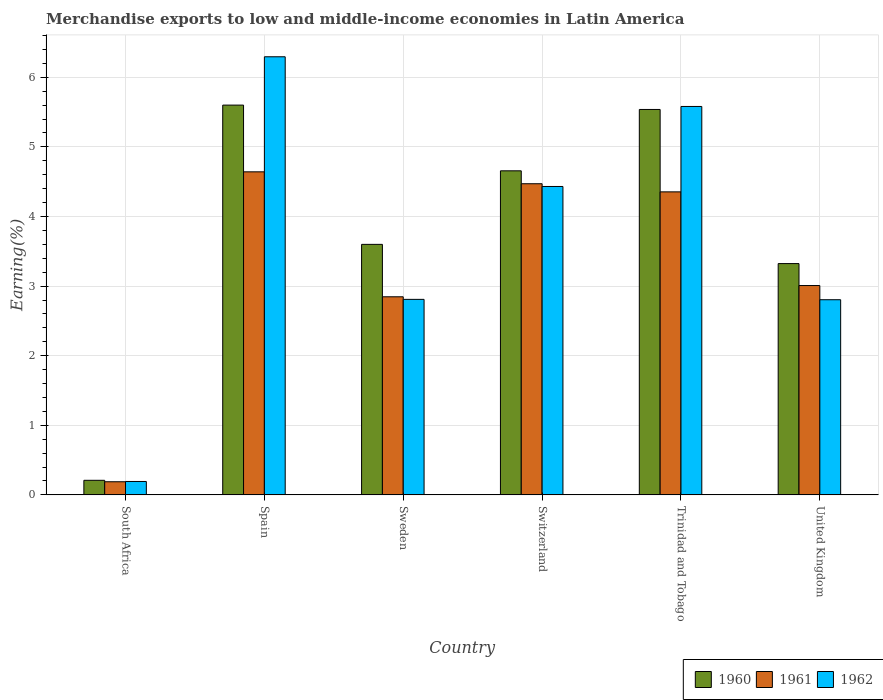How many different coloured bars are there?
Your answer should be compact. 3. How many bars are there on the 2nd tick from the right?
Provide a succinct answer. 3. In how many cases, is the number of bars for a given country not equal to the number of legend labels?
Ensure brevity in your answer.  0. What is the percentage of amount earned from merchandise exports in 1960 in Sweden?
Make the answer very short. 3.6. Across all countries, what is the maximum percentage of amount earned from merchandise exports in 1962?
Your answer should be compact. 6.3. Across all countries, what is the minimum percentage of amount earned from merchandise exports in 1960?
Your response must be concise. 0.21. In which country was the percentage of amount earned from merchandise exports in 1962 maximum?
Offer a terse response. Spain. In which country was the percentage of amount earned from merchandise exports in 1960 minimum?
Make the answer very short. South Africa. What is the total percentage of amount earned from merchandise exports in 1961 in the graph?
Ensure brevity in your answer.  19.51. What is the difference between the percentage of amount earned from merchandise exports in 1960 in South Africa and that in Spain?
Keep it short and to the point. -5.39. What is the difference between the percentage of amount earned from merchandise exports in 1960 in Spain and the percentage of amount earned from merchandise exports in 1961 in South Africa?
Offer a terse response. 5.41. What is the average percentage of amount earned from merchandise exports in 1962 per country?
Ensure brevity in your answer.  3.69. What is the difference between the percentage of amount earned from merchandise exports of/in 1961 and percentage of amount earned from merchandise exports of/in 1962 in Sweden?
Offer a terse response. 0.04. In how many countries, is the percentage of amount earned from merchandise exports in 1962 greater than 2.8 %?
Provide a succinct answer. 5. What is the ratio of the percentage of amount earned from merchandise exports in 1962 in South Africa to that in Switzerland?
Provide a short and direct response. 0.04. What is the difference between the highest and the second highest percentage of amount earned from merchandise exports in 1962?
Provide a succinct answer. -1.15. What is the difference between the highest and the lowest percentage of amount earned from merchandise exports in 1961?
Make the answer very short. 4.45. What does the 1st bar from the left in South Africa represents?
Keep it short and to the point. 1960. What does the 1st bar from the right in Spain represents?
Keep it short and to the point. 1962. How many bars are there?
Keep it short and to the point. 18. Are all the bars in the graph horizontal?
Ensure brevity in your answer.  No. How many countries are there in the graph?
Offer a very short reply. 6. Are the values on the major ticks of Y-axis written in scientific E-notation?
Your answer should be very brief. No. Does the graph contain grids?
Offer a very short reply. Yes. Where does the legend appear in the graph?
Ensure brevity in your answer.  Bottom right. How are the legend labels stacked?
Offer a very short reply. Horizontal. What is the title of the graph?
Make the answer very short. Merchandise exports to low and middle-income economies in Latin America. What is the label or title of the X-axis?
Your answer should be very brief. Country. What is the label or title of the Y-axis?
Provide a succinct answer. Earning(%). What is the Earning(%) in 1960 in South Africa?
Offer a terse response. 0.21. What is the Earning(%) of 1961 in South Africa?
Provide a short and direct response. 0.19. What is the Earning(%) of 1962 in South Africa?
Your answer should be very brief. 0.19. What is the Earning(%) in 1960 in Spain?
Your answer should be compact. 5.6. What is the Earning(%) of 1961 in Spain?
Provide a short and direct response. 4.64. What is the Earning(%) in 1962 in Spain?
Offer a terse response. 6.3. What is the Earning(%) of 1960 in Sweden?
Provide a short and direct response. 3.6. What is the Earning(%) in 1961 in Sweden?
Offer a very short reply. 2.85. What is the Earning(%) of 1962 in Sweden?
Make the answer very short. 2.81. What is the Earning(%) of 1960 in Switzerland?
Give a very brief answer. 4.66. What is the Earning(%) of 1961 in Switzerland?
Keep it short and to the point. 4.47. What is the Earning(%) of 1962 in Switzerland?
Make the answer very short. 4.43. What is the Earning(%) of 1960 in Trinidad and Tobago?
Keep it short and to the point. 5.54. What is the Earning(%) of 1961 in Trinidad and Tobago?
Provide a short and direct response. 4.35. What is the Earning(%) of 1962 in Trinidad and Tobago?
Give a very brief answer. 5.58. What is the Earning(%) in 1960 in United Kingdom?
Ensure brevity in your answer.  3.32. What is the Earning(%) in 1961 in United Kingdom?
Your response must be concise. 3.01. What is the Earning(%) of 1962 in United Kingdom?
Offer a very short reply. 2.8. Across all countries, what is the maximum Earning(%) in 1960?
Offer a terse response. 5.6. Across all countries, what is the maximum Earning(%) of 1961?
Your answer should be compact. 4.64. Across all countries, what is the maximum Earning(%) in 1962?
Provide a succinct answer. 6.3. Across all countries, what is the minimum Earning(%) in 1960?
Give a very brief answer. 0.21. Across all countries, what is the minimum Earning(%) of 1961?
Your response must be concise. 0.19. Across all countries, what is the minimum Earning(%) of 1962?
Your response must be concise. 0.19. What is the total Earning(%) of 1960 in the graph?
Provide a succinct answer. 22.93. What is the total Earning(%) in 1961 in the graph?
Make the answer very short. 19.51. What is the total Earning(%) in 1962 in the graph?
Your answer should be compact. 22.11. What is the difference between the Earning(%) in 1960 in South Africa and that in Spain?
Ensure brevity in your answer.  -5.39. What is the difference between the Earning(%) of 1961 in South Africa and that in Spain?
Ensure brevity in your answer.  -4.45. What is the difference between the Earning(%) of 1962 in South Africa and that in Spain?
Offer a terse response. -6.1. What is the difference between the Earning(%) of 1960 in South Africa and that in Sweden?
Ensure brevity in your answer.  -3.39. What is the difference between the Earning(%) in 1961 in South Africa and that in Sweden?
Offer a very short reply. -2.66. What is the difference between the Earning(%) in 1962 in South Africa and that in Sweden?
Your answer should be very brief. -2.62. What is the difference between the Earning(%) of 1960 in South Africa and that in Switzerland?
Provide a succinct answer. -4.45. What is the difference between the Earning(%) of 1961 in South Africa and that in Switzerland?
Your answer should be very brief. -4.28. What is the difference between the Earning(%) of 1962 in South Africa and that in Switzerland?
Provide a short and direct response. -4.24. What is the difference between the Earning(%) of 1960 in South Africa and that in Trinidad and Tobago?
Offer a terse response. -5.33. What is the difference between the Earning(%) of 1961 in South Africa and that in Trinidad and Tobago?
Provide a succinct answer. -4.17. What is the difference between the Earning(%) in 1962 in South Africa and that in Trinidad and Tobago?
Your response must be concise. -5.39. What is the difference between the Earning(%) of 1960 in South Africa and that in United Kingdom?
Make the answer very short. -3.11. What is the difference between the Earning(%) in 1961 in South Africa and that in United Kingdom?
Make the answer very short. -2.82. What is the difference between the Earning(%) of 1962 in South Africa and that in United Kingdom?
Your answer should be very brief. -2.61. What is the difference between the Earning(%) of 1960 in Spain and that in Sweden?
Offer a very short reply. 2. What is the difference between the Earning(%) of 1961 in Spain and that in Sweden?
Keep it short and to the point. 1.8. What is the difference between the Earning(%) in 1962 in Spain and that in Sweden?
Make the answer very short. 3.49. What is the difference between the Earning(%) in 1960 in Spain and that in Switzerland?
Your answer should be compact. 0.94. What is the difference between the Earning(%) of 1961 in Spain and that in Switzerland?
Give a very brief answer. 0.17. What is the difference between the Earning(%) of 1962 in Spain and that in Switzerland?
Offer a terse response. 1.86. What is the difference between the Earning(%) in 1960 in Spain and that in Trinidad and Tobago?
Make the answer very short. 0.06. What is the difference between the Earning(%) of 1961 in Spain and that in Trinidad and Tobago?
Your response must be concise. 0.29. What is the difference between the Earning(%) in 1962 in Spain and that in Trinidad and Tobago?
Make the answer very short. 0.71. What is the difference between the Earning(%) of 1960 in Spain and that in United Kingdom?
Keep it short and to the point. 2.28. What is the difference between the Earning(%) in 1961 in Spain and that in United Kingdom?
Give a very brief answer. 1.63. What is the difference between the Earning(%) of 1962 in Spain and that in United Kingdom?
Your answer should be compact. 3.49. What is the difference between the Earning(%) of 1960 in Sweden and that in Switzerland?
Ensure brevity in your answer.  -1.06. What is the difference between the Earning(%) of 1961 in Sweden and that in Switzerland?
Offer a very short reply. -1.62. What is the difference between the Earning(%) of 1962 in Sweden and that in Switzerland?
Ensure brevity in your answer.  -1.62. What is the difference between the Earning(%) in 1960 in Sweden and that in Trinidad and Tobago?
Give a very brief answer. -1.94. What is the difference between the Earning(%) of 1961 in Sweden and that in Trinidad and Tobago?
Make the answer very short. -1.51. What is the difference between the Earning(%) of 1962 in Sweden and that in Trinidad and Tobago?
Your response must be concise. -2.77. What is the difference between the Earning(%) in 1960 in Sweden and that in United Kingdom?
Your answer should be compact. 0.28. What is the difference between the Earning(%) in 1961 in Sweden and that in United Kingdom?
Offer a very short reply. -0.16. What is the difference between the Earning(%) in 1962 in Sweden and that in United Kingdom?
Your answer should be compact. 0.01. What is the difference between the Earning(%) of 1960 in Switzerland and that in Trinidad and Tobago?
Make the answer very short. -0.88. What is the difference between the Earning(%) of 1961 in Switzerland and that in Trinidad and Tobago?
Provide a short and direct response. 0.12. What is the difference between the Earning(%) of 1962 in Switzerland and that in Trinidad and Tobago?
Ensure brevity in your answer.  -1.15. What is the difference between the Earning(%) in 1960 in Switzerland and that in United Kingdom?
Your answer should be compact. 1.33. What is the difference between the Earning(%) in 1961 in Switzerland and that in United Kingdom?
Your response must be concise. 1.46. What is the difference between the Earning(%) in 1962 in Switzerland and that in United Kingdom?
Keep it short and to the point. 1.63. What is the difference between the Earning(%) of 1960 in Trinidad and Tobago and that in United Kingdom?
Provide a succinct answer. 2.21. What is the difference between the Earning(%) in 1961 in Trinidad and Tobago and that in United Kingdom?
Ensure brevity in your answer.  1.35. What is the difference between the Earning(%) in 1962 in Trinidad and Tobago and that in United Kingdom?
Ensure brevity in your answer.  2.78. What is the difference between the Earning(%) of 1960 in South Africa and the Earning(%) of 1961 in Spain?
Offer a very short reply. -4.43. What is the difference between the Earning(%) in 1960 in South Africa and the Earning(%) in 1962 in Spain?
Provide a short and direct response. -6.09. What is the difference between the Earning(%) in 1961 in South Africa and the Earning(%) in 1962 in Spain?
Ensure brevity in your answer.  -6.11. What is the difference between the Earning(%) of 1960 in South Africa and the Earning(%) of 1961 in Sweden?
Keep it short and to the point. -2.64. What is the difference between the Earning(%) of 1960 in South Africa and the Earning(%) of 1962 in Sweden?
Provide a short and direct response. -2.6. What is the difference between the Earning(%) in 1961 in South Africa and the Earning(%) in 1962 in Sweden?
Keep it short and to the point. -2.62. What is the difference between the Earning(%) of 1960 in South Africa and the Earning(%) of 1961 in Switzerland?
Provide a short and direct response. -4.26. What is the difference between the Earning(%) of 1960 in South Africa and the Earning(%) of 1962 in Switzerland?
Your answer should be very brief. -4.22. What is the difference between the Earning(%) in 1961 in South Africa and the Earning(%) in 1962 in Switzerland?
Your answer should be very brief. -4.24. What is the difference between the Earning(%) of 1960 in South Africa and the Earning(%) of 1961 in Trinidad and Tobago?
Your answer should be very brief. -4.14. What is the difference between the Earning(%) in 1960 in South Africa and the Earning(%) in 1962 in Trinidad and Tobago?
Give a very brief answer. -5.37. What is the difference between the Earning(%) of 1961 in South Africa and the Earning(%) of 1962 in Trinidad and Tobago?
Offer a very short reply. -5.39. What is the difference between the Earning(%) in 1960 in South Africa and the Earning(%) in 1961 in United Kingdom?
Make the answer very short. -2.8. What is the difference between the Earning(%) in 1960 in South Africa and the Earning(%) in 1962 in United Kingdom?
Your answer should be very brief. -2.59. What is the difference between the Earning(%) in 1961 in South Africa and the Earning(%) in 1962 in United Kingdom?
Your answer should be compact. -2.62. What is the difference between the Earning(%) in 1960 in Spain and the Earning(%) in 1961 in Sweden?
Provide a succinct answer. 2.75. What is the difference between the Earning(%) of 1960 in Spain and the Earning(%) of 1962 in Sweden?
Ensure brevity in your answer.  2.79. What is the difference between the Earning(%) of 1961 in Spain and the Earning(%) of 1962 in Sweden?
Make the answer very short. 1.83. What is the difference between the Earning(%) in 1960 in Spain and the Earning(%) in 1961 in Switzerland?
Your response must be concise. 1.13. What is the difference between the Earning(%) in 1960 in Spain and the Earning(%) in 1962 in Switzerland?
Offer a very short reply. 1.17. What is the difference between the Earning(%) in 1961 in Spain and the Earning(%) in 1962 in Switzerland?
Your answer should be compact. 0.21. What is the difference between the Earning(%) of 1960 in Spain and the Earning(%) of 1961 in Trinidad and Tobago?
Offer a terse response. 1.25. What is the difference between the Earning(%) of 1960 in Spain and the Earning(%) of 1962 in Trinidad and Tobago?
Your response must be concise. 0.02. What is the difference between the Earning(%) in 1961 in Spain and the Earning(%) in 1962 in Trinidad and Tobago?
Offer a very short reply. -0.94. What is the difference between the Earning(%) in 1960 in Spain and the Earning(%) in 1961 in United Kingdom?
Keep it short and to the point. 2.59. What is the difference between the Earning(%) in 1960 in Spain and the Earning(%) in 1962 in United Kingdom?
Your answer should be compact. 2.8. What is the difference between the Earning(%) in 1961 in Spain and the Earning(%) in 1962 in United Kingdom?
Your answer should be very brief. 1.84. What is the difference between the Earning(%) of 1960 in Sweden and the Earning(%) of 1961 in Switzerland?
Provide a short and direct response. -0.87. What is the difference between the Earning(%) in 1960 in Sweden and the Earning(%) in 1962 in Switzerland?
Keep it short and to the point. -0.83. What is the difference between the Earning(%) in 1961 in Sweden and the Earning(%) in 1962 in Switzerland?
Ensure brevity in your answer.  -1.58. What is the difference between the Earning(%) of 1960 in Sweden and the Earning(%) of 1961 in Trinidad and Tobago?
Provide a short and direct response. -0.75. What is the difference between the Earning(%) in 1960 in Sweden and the Earning(%) in 1962 in Trinidad and Tobago?
Offer a terse response. -1.98. What is the difference between the Earning(%) of 1961 in Sweden and the Earning(%) of 1962 in Trinidad and Tobago?
Make the answer very short. -2.73. What is the difference between the Earning(%) of 1960 in Sweden and the Earning(%) of 1961 in United Kingdom?
Your answer should be compact. 0.59. What is the difference between the Earning(%) in 1960 in Sweden and the Earning(%) in 1962 in United Kingdom?
Provide a succinct answer. 0.8. What is the difference between the Earning(%) of 1961 in Sweden and the Earning(%) of 1962 in United Kingdom?
Offer a terse response. 0.04. What is the difference between the Earning(%) of 1960 in Switzerland and the Earning(%) of 1961 in Trinidad and Tobago?
Provide a short and direct response. 0.3. What is the difference between the Earning(%) of 1960 in Switzerland and the Earning(%) of 1962 in Trinidad and Tobago?
Provide a succinct answer. -0.92. What is the difference between the Earning(%) in 1961 in Switzerland and the Earning(%) in 1962 in Trinidad and Tobago?
Your response must be concise. -1.11. What is the difference between the Earning(%) in 1960 in Switzerland and the Earning(%) in 1961 in United Kingdom?
Make the answer very short. 1.65. What is the difference between the Earning(%) of 1960 in Switzerland and the Earning(%) of 1962 in United Kingdom?
Give a very brief answer. 1.85. What is the difference between the Earning(%) of 1961 in Switzerland and the Earning(%) of 1962 in United Kingdom?
Provide a succinct answer. 1.67. What is the difference between the Earning(%) of 1960 in Trinidad and Tobago and the Earning(%) of 1961 in United Kingdom?
Your response must be concise. 2.53. What is the difference between the Earning(%) in 1960 in Trinidad and Tobago and the Earning(%) in 1962 in United Kingdom?
Offer a very short reply. 2.73. What is the difference between the Earning(%) in 1961 in Trinidad and Tobago and the Earning(%) in 1962 in United Kingdom?
Make the answer very short. 1.55. What is the average Earning(%) of 1960 per country?
Offer a very short reply. 3.82. What is the average Earning(%) in 1961 per country?
Offer a terse response. 3.25. What is the average Earning(%) in 1962 per country?
Make the answer very short. 3.69. What is the difference between the Earning(%) of 1960 and Earning(%) of 1961 in South Africa?
Provide a succinct answer. 0.02. What is the difference between the Earning(%) of 1960 and Earning(%) of 1962 in South Africa?
Your answer should be compact. 0.02. What is the difference between the Earning(%) in 1961 and Earning(%) in 1962 in South Africa?
Offer a very short reply. -0. What is the difference between the Earning(%) of 1960 and Earning(%) of 1961 in Spain?
Give a very brief answer. 0.96. What is the difference between the Earning(%) in 1960 and Earning(%) in 1962 in Spain?
Your response must be concise. -0.69. What is the difference between the Earning(%) of 1961 and Earning(%) of 1962 in Spain?
Your answer should be very brief. -1.65. What is the difference between the Earning(%) in 1960 and Earning(%) in 1961 in Sweden?
Give a very brief answer. 0.75. What is the difference between the Earning(%) of 1960 and Earning(%) of 1962 in Sweden?
Offer a very short reply. 0.79. What is the difference between the Earning(%) in 1961 and Earning(%) in 1962 in Sweden?
Offer a very short reply. 0.04. What is the difference between the Earning(%) in 1960 and Earning(%) in 1961 in Switzerland?
Provide a succinct answer. 0.19. What is the difference between the Earning(%) of 1960 and Earning(%) of 1962 in Switzerland?
Your response must be concise. 0.23. What is the difference between the Earning(%) in 1961 and Earning(%) in 1962 in Switzerland?
Provide a succinct answer. 0.04. What is the difference between the Earning(%) of 1960 and Earning(%) of 1961 in Trinidad and Tobago?
Ensure brevity in your answer.  1.18. What is the difference between the Earning(%) in 1960 and Earning(%) in 1962 in Trinidad and Tobago?
Make the answer very short. -0.04. What is the difference between the Earning(%) in 1961 and Earning(%) in 1962 in Trinidad and Tobago?
Keep it short and to the point. -1.23. What is the difference between the Earning(%) of 1960 and Earning(%) of 1961 in United Kingdom?
Make the answer very short. 0.32. What is the difference between the Earning(%) in 1960 and Earning(%) in 1962 in United Kingdom?
Provide a short and direct response. 0.52. What is the difference between the Earning(%) of 1961 and Earning(%) of 1962 in United Kingdom?
Keep it short and to the point. 0.2. What is the ratio of the Earning(%) of 1960 in South Africa to that in Spain?
Provide a short and direct response. 0.04. What is the ratio of the Earning(%) in 1961 in South Africa to that in Spain?
Keep it short and to the point. 0.04. What is the ratio of the Earning(%) of 1962 in South Africa to that in Spain?
Your response must be concise. 0.03. What is the ratio of the Earning(%) of 1960 in South Africa to that in Sweden?
Your answer should be very brief. 0.06. What is the ratio of the Earning(%) of 1961 in South Africa to that in Sweden?
Your answer should be compact. 0.07. What is the ratio of the Earning(%) of 1962 in South Africa to that in Sweden?
Your answer should be very brief. 0.07. What is the ratio of the Earning(%) of 1960 in South Africa to that in Switzerland?
Ensure brevity in your answer.  0.04. What is the ratio of the Earning(%) of 1961 in South Africa to that in Switzerland?
Keep it short and to the point. 0.04. What is the ratio of the Earning(%) in 1962 in South Africa to that in Switzerland?
Ensure brevity in your answer.  0.04. What is the ratio of the Earning(%) in 1960 in South Africa to that in Trinidad and Tobago?
Your response must be concise. 0.04. What is the ratio of the Earning(%) of 1961 in South Africa to that in Trinidad and Tobago?
Your response must be concise. 0.04. What is the ratio of the Earning(%) in 1962 in South Africa to that in Trinidad and Tobago?
Provide a succinct answer. 0.03. What is the ratio of the Earning(%) of 1960 in South Africa to that in United Kingdom?
Provide a succinct answer. 0.06. What is the ratio of the Earning(%) in 1961 in South Africa to that in United Kingdom?
Your response must be concise. 0.06. What is the ratio of the Earning(%) in 1962 in South Africa to that in United Kingdom?
Keep it short and to the point. 0.07. What is the ratio of the Earning(%) in 1960 in Spain to that in Sweden?
Your answer should be compact. 1.56. What is the ratio of the Earning(%) of 1961 in Spain to that in Sweden?
Your answer should be very brief. 1.63. What is the ratio of the Earning(%) of 1962 in Spain to that in Sweden?
Provide a succinct answer. 2.24. What is the ratio of the Earning(%) in 1960 in Spain to that in Switzerland?
Keep it short and to the point. 1.2. What is the ratio of the Earning(%) of 1961 in Spain to that in Switzerland?
Provide a short and direct response. 1.04. What is the ratio of the Earning(%) in 1962 in Spain to that in Switzerland?
Your response must be concise. 1.42. What is the ratio of the Earning(%) in 1960 in Spain to that in Trinidad and Tobago?
Provide a succinct answer. 1.01. What is the ratio of the Earning(%) in 1961 in Spain to that in Trinidad and Tobago?
Your answer should be compact. 1.07. What is the ratio of the Earning(%) in 1962 in Spain to that in Trinidad and Tobago?
Keep it short and to the point. 1.13. What is the ratio of the Earning(%) of 1960 in Spain to that in United Kingdom?
Offer a terse response. 1.69. What is the ratio of the Earning(%) of 1961 in Spain to that in United Kingdom?
Ensure brevity in your answer.  1.54. What is the ratio of the Earning(%) in 1962 in Spain to that in United Kingdom?
Offer a terse response. 2.24. What is the ratio of the Earning(%) in 1960 in Sweden to that in Switzerland?
Provide a succinct answer. 0.77. What is the ratio of the Earning(%) in 1961 in Sweden to that in Switzerland?
Offer a very short reply. 0.64. What is the ratio of the Earning(%) of 1962 in Sweden to that in Switzerland?
Make the answer very short. 0.63. What is the ratio of the Earning(%) of 1960 in Sweden to that in Trinidad and Tobago?
Offer a terse response. 0.65. What is the ratio of the Earning(%) in 1961 in Sweden to that in Trinidad and Tobago?
Ensure brevity in your answer.  0.65. What is the ratio of the Earning(%) of 1962 in Sweden to that in Trinidad and Tobago?
Offer a terse response. 0.5. What is the ratio of the Earning(%) of 1960 in Sweden to that in United Kingdom?
Give a very brief answer. 1.08. What is the ratio of the Earning(%) of 1961 in Sweden to that in United Kingdom?
Offer a very short reply. 0.95. What is the ratio of the Earning(%) of 1962 in Sweden to that in United Kingdom?
Offer a very short reply. 1. What is the ratio of the Earning(%) of 1960 in Switzerland to that in Trinidad and Tobago?
Keep it short and to the point. 0.84. What is the ratio of the Earning(%) in 1961 in Switzerland to that in Trinidad and Tobago?
Your answer should be compact. 1.03. What is the ratio of the Earning(%) of 1962 in Switzerland to that in Trinidad and Tobago?
Provide a succinct answer. 0.79. What is the ratio of the Earning(%) in 1960 in Switzerland to that in United Kingdom?
Give a very brief answer. 1.4. What is the ratio of the Earning(%) of 1961 in Switzerland to that in United Kingdom?
Your response must be concise. 1.49. What is the ratio of the Earning(%) of 1962 in Switzerland to that in United Kingdom?
Your response must be concise. 1.58. What is the ratio of the Earning(%) of 1960 in Trinidad and Tobago to that in United Kingdom?
Your answer should be very brief. 1.67. What is the ratio of the Earning(%) in 1961 in Trinidad and Tobago to that in United Kingdom?
Your answer should be compact. 1.45. What is the ratio of the Earning(%) of 1962 in Trinidad and Tobago to that in United Kingdom?
Give a very brief answer. 1.99. What is the difference between the highest and the second highest Earning(%) of 1960?
Provide a short and direct response. 0.06. What is the difference between the highest and the second highest Earning(%) in 1961?
Give a very brief answer. 0.17. What is the difference between the highest and the second highest Earning(%) in 1962?
Provide a short and direct response. 0.71. What is the difference between the highest and the lowest Earning(%) of 1960?
Offer a terse response. 5.39. What is the difference between the highest and the lowest Earning(%) in 1961?
Ensure brevity in your answer.  4.45. What is the difference between the highest and the lowest Earning(%) in 1962?
Make the answer very short. 6.1. 